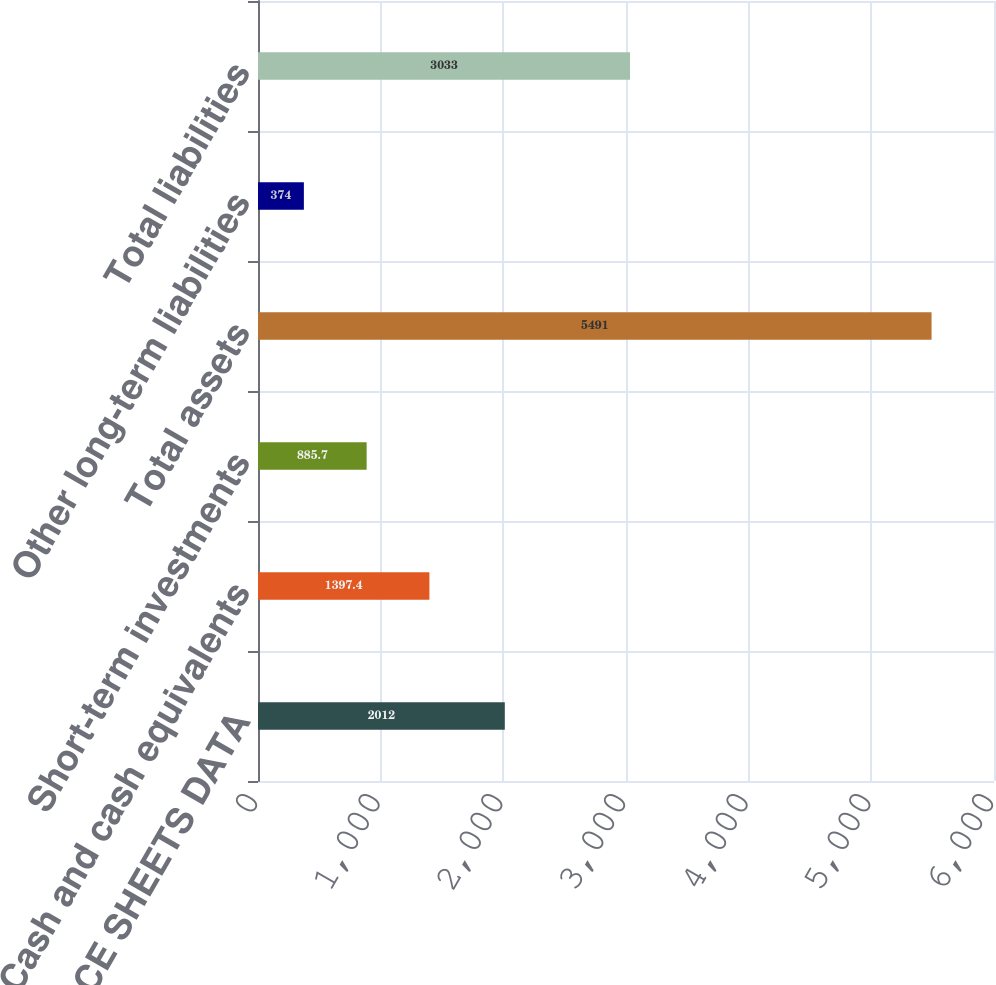Convert chart to OTSL. <chart><loc_0><loc_0><loc_500><loc_500><bar_chart><fcel>BALANCE SHEETS DATA<fcel>Cash and cash equivalents<fcel>Short-term investments<fcel>Total assets<fcel>Other long-term liabilities<fcel>Total liabilities<nl><fcel>2012<fcel>1397.4<fcel>885.7<fcel>5491<fcel>374<fcel>3033<nl></chart> 